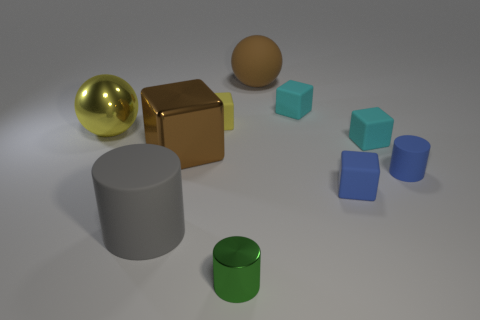Subtract 1 cubes. How many cubes are left? 4 Subtract all yellow blocks. How many blocks are left? 4 Subtract all metal cubes. How many cubes are left? 4 Subtract all green blocks. Subtract all blue cylinders. How many blocks are left? 5 Subtract all spheres. How many objects are left? 8 Add 1 yellow shiny objects. How many yellow shiny objects are left? 2 Add 5 tiny yellow cubes. How many tiny yellow cubes exist? 6 Subtract 1 brown spheres. How many objects are left? 9 Subtract all small rubber cylinders. Subtract all cyan cubes. How many objects are left? 7 